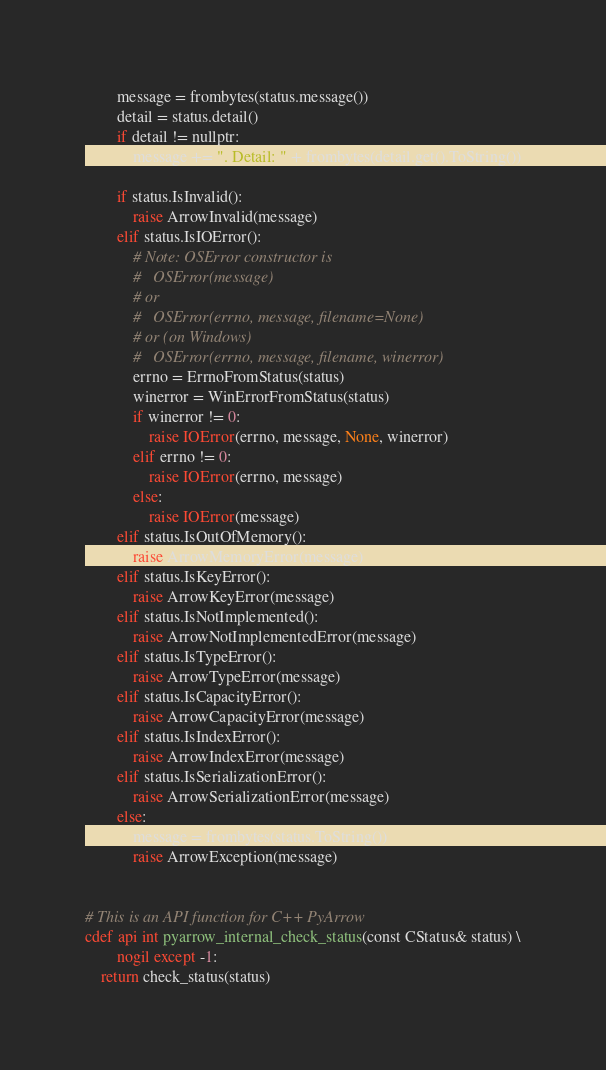<code> <loc_0><loc_0><loc_500><loc_500><_Cython_>        message = frombytes(status.message())
        detail = status.detail()
        if detail != nullptr:
            message += ". Detail: " + frombytes(detail.get().ToString())

        if status.IsInvalid():
            raise ArrowInvalid(message)
        elif status.IsIOError():
            # Note: OSError constructor is
            #   OSError(message)
            # or
            #   OSError(errno, message, filename=None)
            # or (on Windows)
            #   OSError(errno, message, filename, winerror)
            errno = ErrnoFromStatus(status)
            winerror = WinErrorFromStatus(status)
            if winerror != 0:
                raise IOError(errno, message, None, winerror)
            elif errno != 0:
                raise IOError(errno, message)
            else:
                raise IOError(message)
        elif status.IsOutOfMemory():
            raise ArrowMemoryError(message)
        elif status.IsKeyError():
            raise ArrowKeyError(message)
        elif status.IsNotImplemented():
            raise ArrowNotImplementedError(message)
        elif status.IsTypeError():
            raise ArrowTypeError(message)
        elif status.IsCapacityError():
            raise ArrowCapacityError(message)
        elif status.IsIndexError():
            raise ArrowIndexError(message)
        elif status.IsSerializationError():
            raise ArrowSerializationError(message)
        else:
            message = frombytes(status.ToString())
            raise ArrowException(message)


# This is an API function for C++ PyArrow
cdef api int pyarrow_internal_check_status(const CStatus& status) \
        nogil except -1:
    return check_status(status)
</code> 